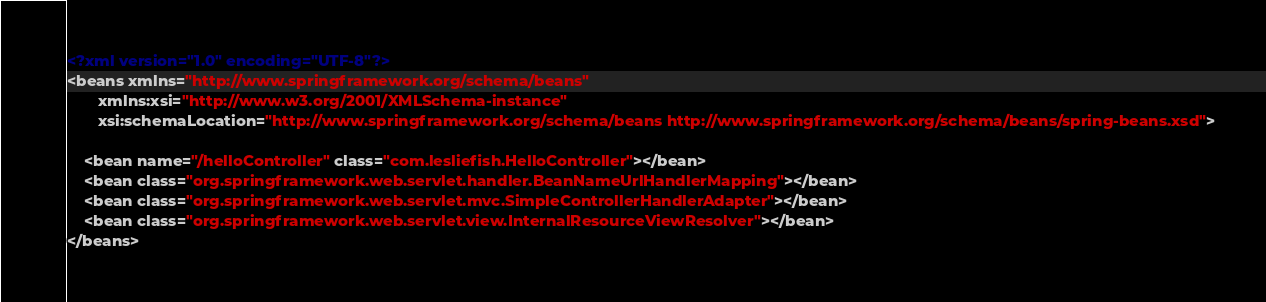<code> <loc_0><loc_0><loc_500><loc_500><_XML_><?xml version="1.0" encoding="UTF-8"?>
<beans xmlns="http://www.springframework.org/schema/beans"
       xmlns:xsi="http://www.w3.org/2001/XMLSchema-instance"
       xsi:schemaLocation="http://www.springframework.org/schema/beans http://www.springframework.org/schema/beans/spring-beans.xsd">

    <bean name="/helloController" class="com.lesliefish.HelloController"></bean>
    <bean class="org.springframework.web.servlet.handler.BeanNameUrlHandlerMapping"></bean>
    <bean class="org.springframework.web.servlet.mvc.SimpleControllerHandlerAdapter"></bean>
    <bean class="org.springframework.web.servlet.view.InternalResourceViewResolver"></bean>
</beans></code> 